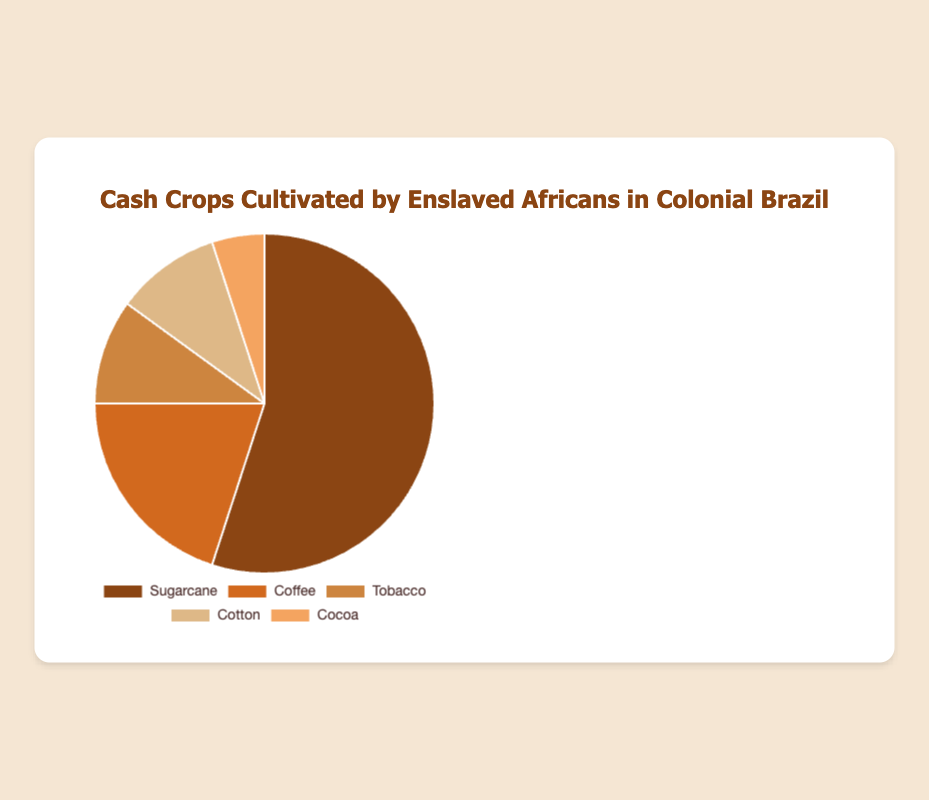What percentage of the total cultivated crops does Sugarcane represent? Sugarcane is shown to represent 55% of the total crops. This value can be directly read from the pie chart as the value associated with Sugarcane.
Answer: 55% Between Coffee and Cocoa, which crop has a higher percentage, and by how much? Coffee represents 20% and Cocoa represents 5%. To find the difference, subtract Cocoa's percentage from Coffee's percentage: 20% - 5% = 15%. So, Coffee has a higher percentage by 15%.
Answer: Coffee is higher by 15% What is the combined percentage of Tobacco and Cotton? Tobacco represents 10% and Cotton also represents 10%. Adding these percentages together gives 10% + 10% = 20%.
Answer: 20% If the total percentage for all crops is 100%, what percentage is represented by all crops other than Sugarcane? Sugarcane represents 55%. The total for all crops is 100%. Subtracting Sugarcane's percentage gives us 100% - 55% = 45%.
Answer: 45% Which crop represents the smallest percentage, and what is that percentage? The pie chart shows that Cocoa represents the smallest percentage, which is 5%.
Answer: Cocoa, 5% How much higher is the percentage of Coffee compared to Cotton? Both Coffee and Cotton’s percentages are mentioned as 20% and 10% respectively. Subtracting Cotton's percentage from Coffee's gives us 20% - 10% = 10%.
Answer: 10% higher What is the average percentage for all the crops shown? To calculate the average, add all percentages and divide by the number of crops: (55% + 20% + 10% + 10% + 5%) = 100%. There are 5 crops. Therefore, 100% / 5 = 20%.
Answer: 20% What color is used to represent Coffee on the pie chart? The color associated with Coffee in the pie chart is visually distinguishable. According to the legend, Coffee is represented in brown.
Answer: Brown If the area representing Tobacco were twice as large, what would the new percentage be? Currently, Tobacco represents 10%. If it were twice as large, this would multiply the percentage by 2, giving us 10% * 2 = 20%.
Answer: 20% Among the five crops, which ones are represented by an equal percentage in the pie chart? The pie chart shows that Tobacco and Cotton are both represented by the same percentage, which is 10% each.
Answer: Tobacco and Cotton 